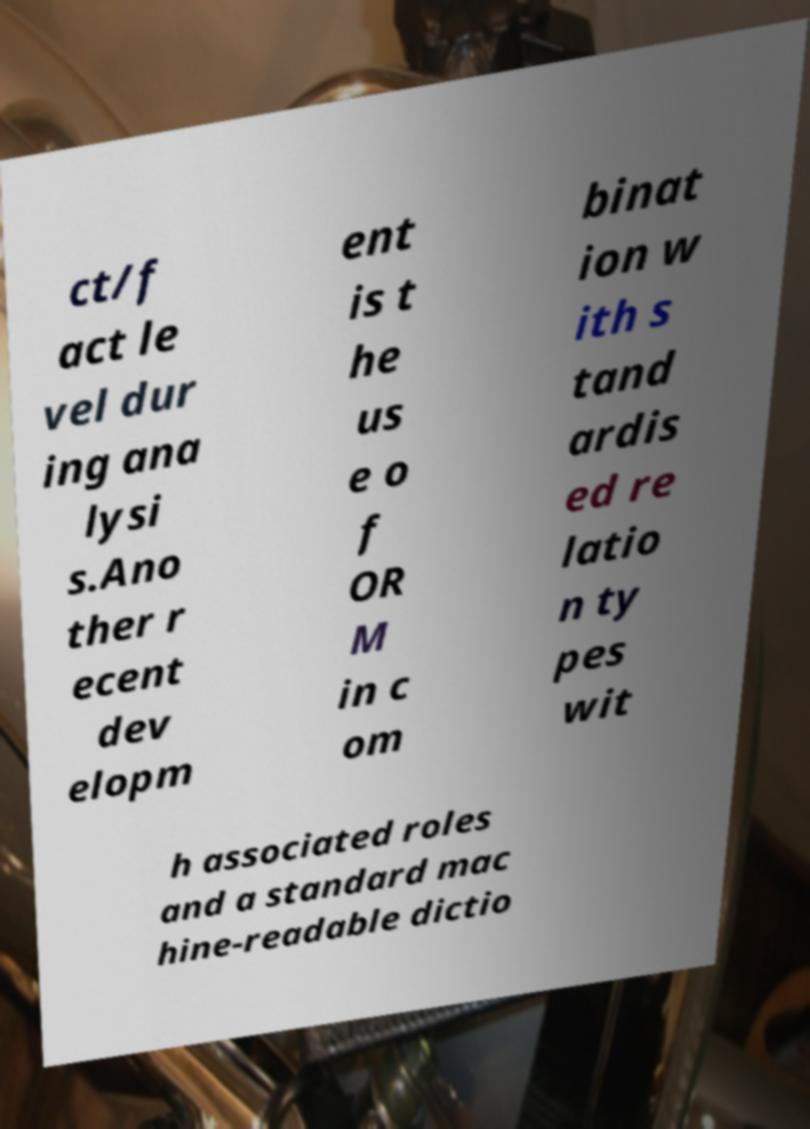I need the written content from this picture converted into text. Can you do that? ct/f act le vel dur ing ana lysi s.Ano ther r ecent dev elopm ent is t he us e o f OR M in c om binat ion w ith s tand ardis ed re latio n ty pes wit h associated roles and a standard mac hine-readable dictio 